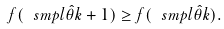Convert formula to latex. <formula><loc_0><loc_0><loc_500><loc_500>f ( \ s m p l { \hat { \theta } } { k + 1 } ) \geq f ( \ s m p l { \hat { \theta } } { k } ) .</formula> 